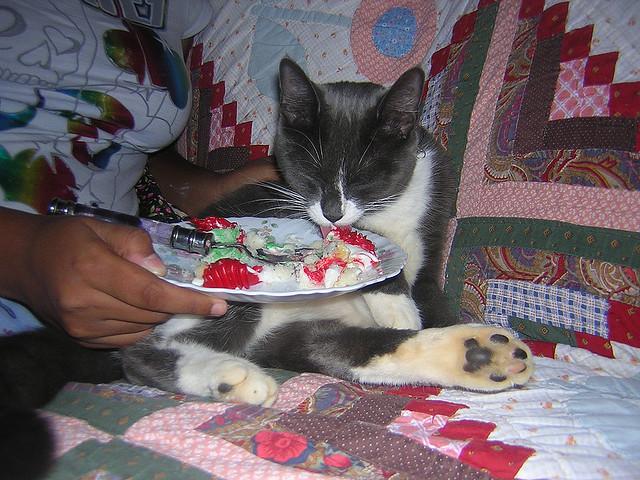What does it mean if the cat's eyes are closed?
Answer briefly. Content. What type of animal is that?
Answer briefly. Cat. Is the cat eating a salad?
Write a very short answer. No. What the color eating?
Concise answer only. Red. 